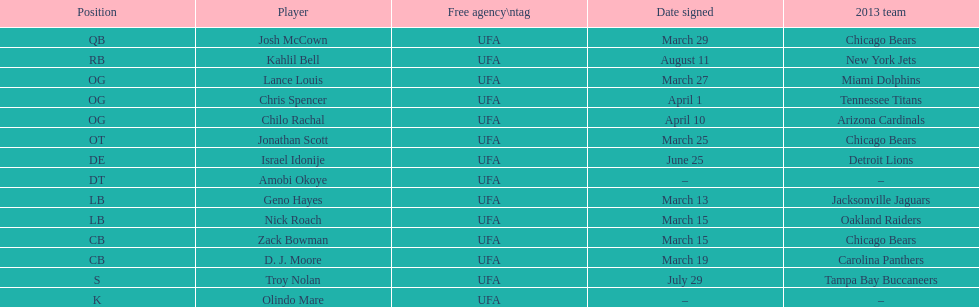Surname is also a given name starting with "n" Troy Nolan. 